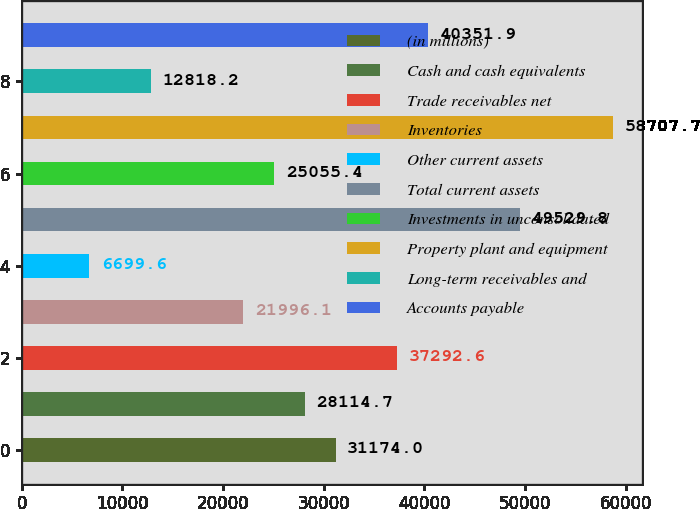<chart> <loc_0><loc_0><loc_500><loc_500><bar_chart><fcel>(in millions)<fcel>Cash and cash equivalents<fcel>Trade receivables net<fcel>Inventories<fcel>Other current assets<fcel>Total current assets<fcel>Investments in unconsolidated<fcel>Property plant and equipment<fcel>Long-term receivables and<fcel>Accounts payable<nl><fcel>31174<fcel>28114.7<fcel>37292.6<fcel>21996.1<fcel>6699.6<fcel>49529.8<fcel>25055.4<fcel>58707.7<fcel>12818.2<fcel>40351.9<nl></chart> 